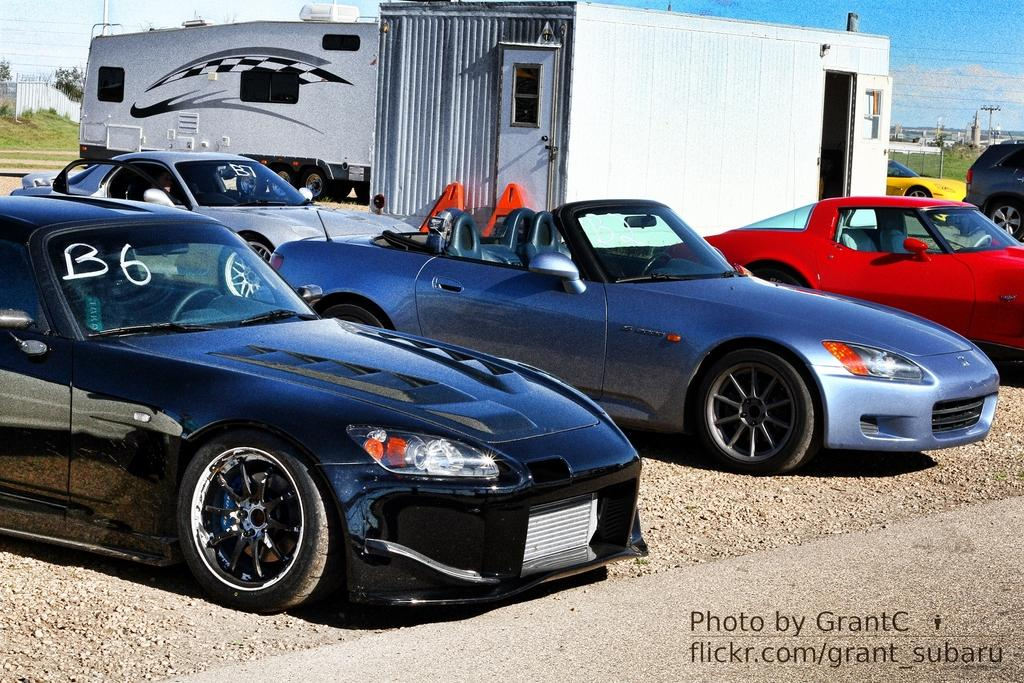What types of vehicles are in the image? There are vehicles in the image, but the specific types are not mentioned. What structure can be seen in the image? There is a cabin in the image. What can be seen in the background of the image? There are poles, grass, and clouds visible in the background of the image. Where is the text located in the image? The text is at the right bottom of the image. What type of sweater is the person wearing in the image? There is no person wearing a sweater in the image. How many items are on the list in the image? There is no list present in the image. 